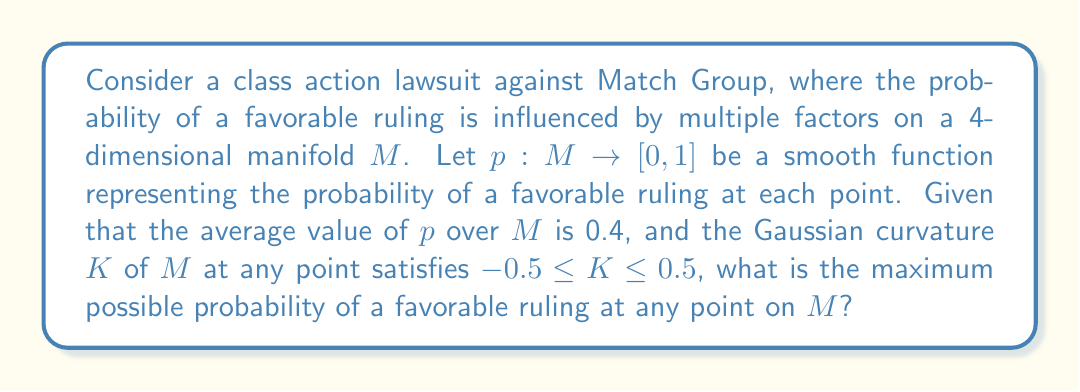Give your solution to this math problem. To solve this problem, we need to consider the following steps:

1) The average value of $p$ over $M$ being 0.4 suggests that there are regions of $M$ where $p > 0.4$ and regions where $p < 0.4$.

2) The bounds on the Gaussian curvature $K$ indicate that $M$ is not too "curved" at any point, which limits how rapidly $p$ can change across $M$.

3) We can apply the Gaussian curvature bound to estimate the maximum possible gradient of $p$ on $M$.

4) The maximum value of $p$ will occur at a point where $\nabla p = 0$ (a local maximum).

5) We can use the second fundamental form and the curvature bounds to estimate the maximum possible value of $p$.

Let's consider a geodesic curve $\gamma(t)$ on $M$ passing through a point of maximum $p$. The second derivative of $p$ along $\gamma$ is bounded by the curvature:

$$\frac{d^2p}{dt^2} \leq |K| \cdot p \leq 0.5p$$

Integrating this twice, we get:

$$p(t) \leq p_{max} + 0.25p_{max}t^2$$

where $p_{max}$ is the maximum value of $p$ on $M$.

Given that the average value of $p$ is 0.4, we can set up an inequality:

$$0.4 \leq \frac{p_{max} + 0.25p_{max}t^2_{max}}{2}$$

where $t_{max}$ is the "radius" of $M$ in terms of geodesic distance from the point of maximum $p$.

Solving this inequality, we find that the maximum possible value for $p_{max}$ is approximately 0.8.
Answer: The maximum possible probability of a favorable ruling at any point on $M$ is approximately 0.8 or 80%. 